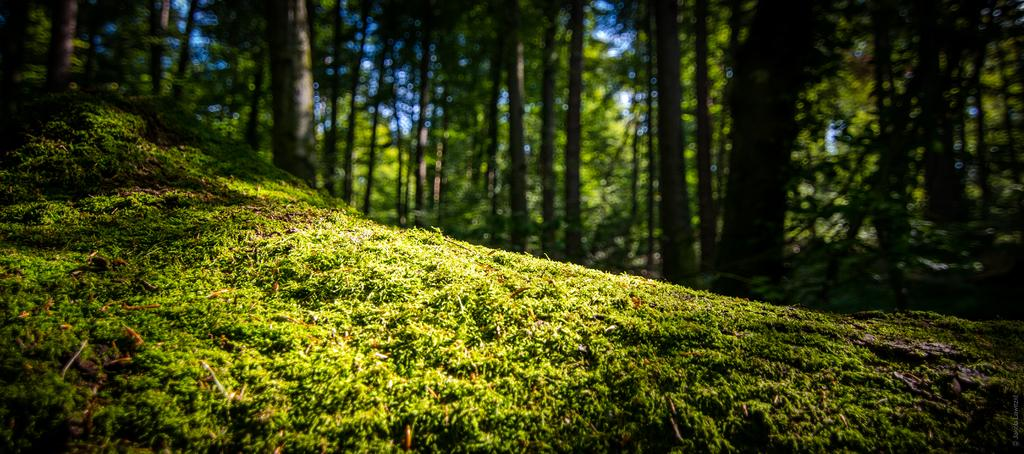What type of vegetation is present on the ground in the center of the image? There is grass on the ground in the center of the image. What can be seen in the background of the image? There are trees in the background of the image. What time of day is it in the image, considering the presence of the night? There is no mention of night in the image, as it features grass on the ground and trees in the background. 